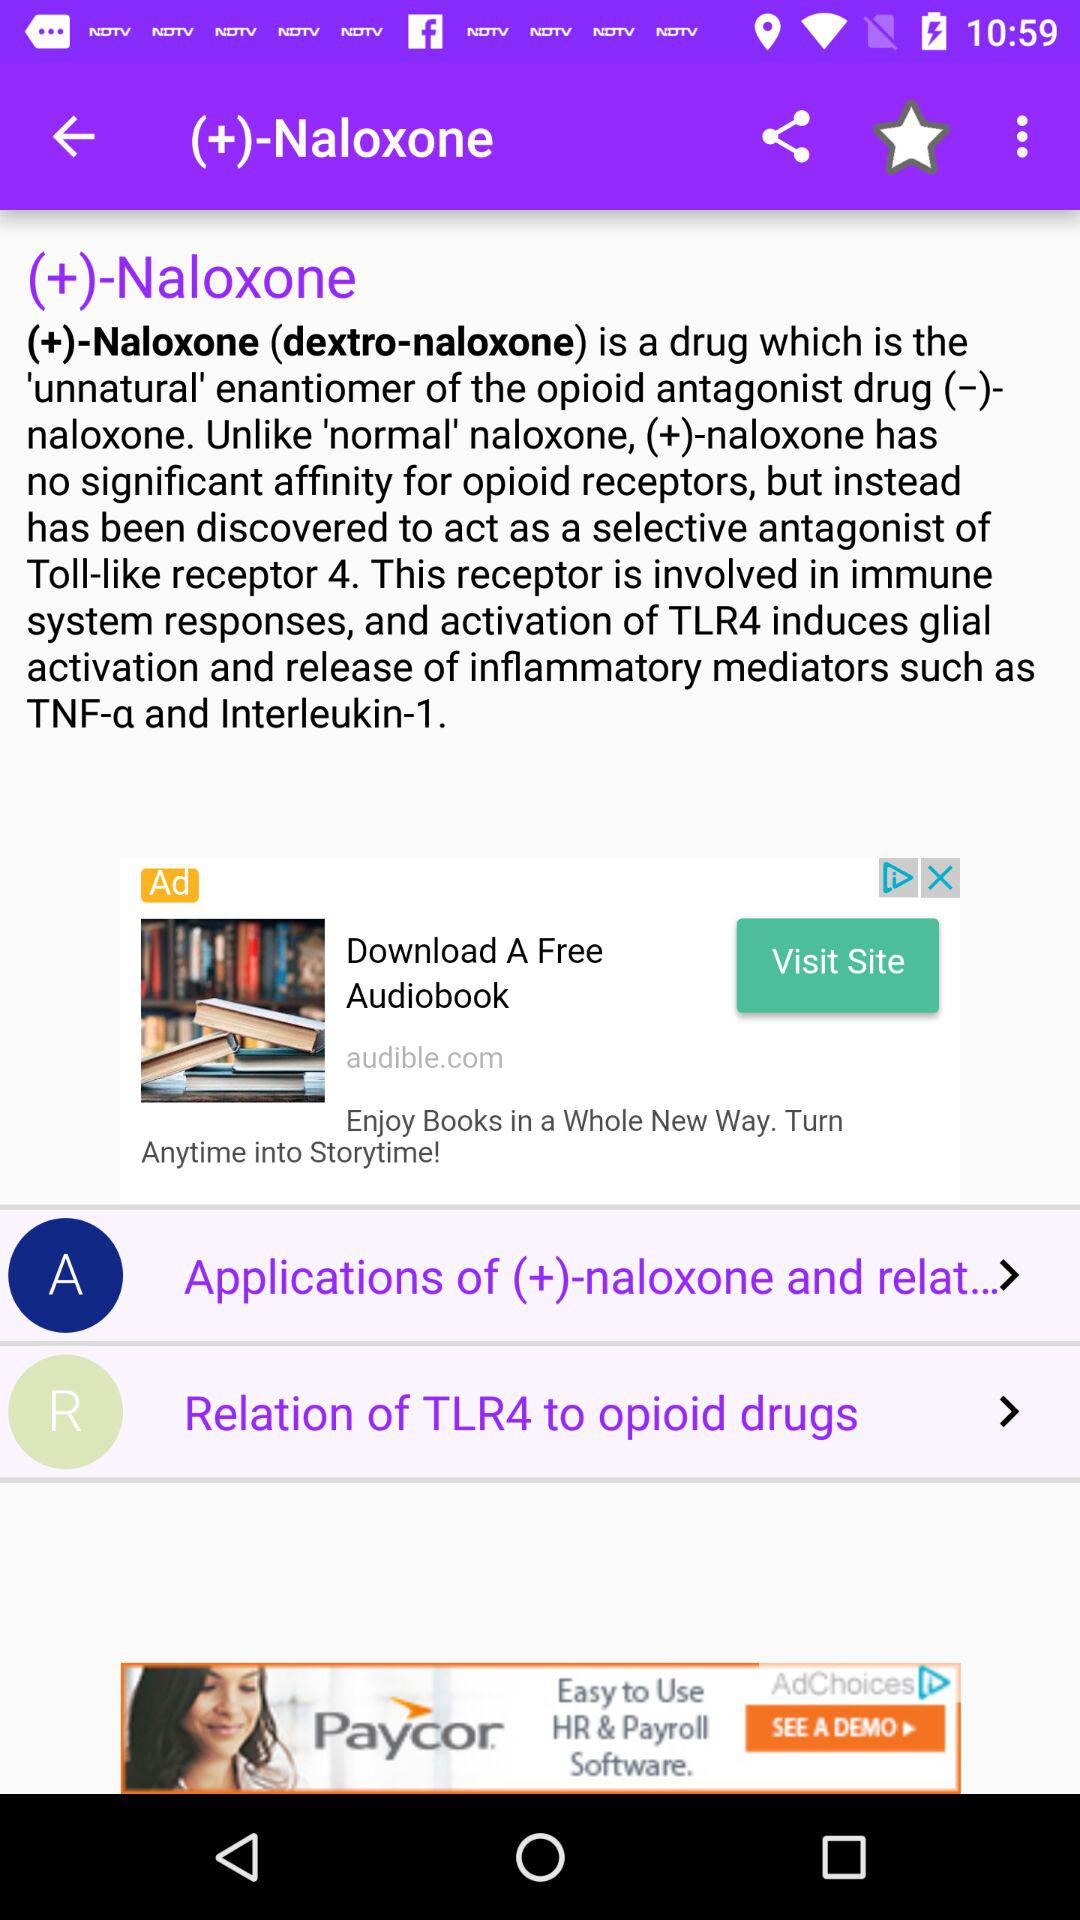What is the mentioned drug's name? The mentioned drug's name is "(+)-Naloxone (dextro-naloxone)". 